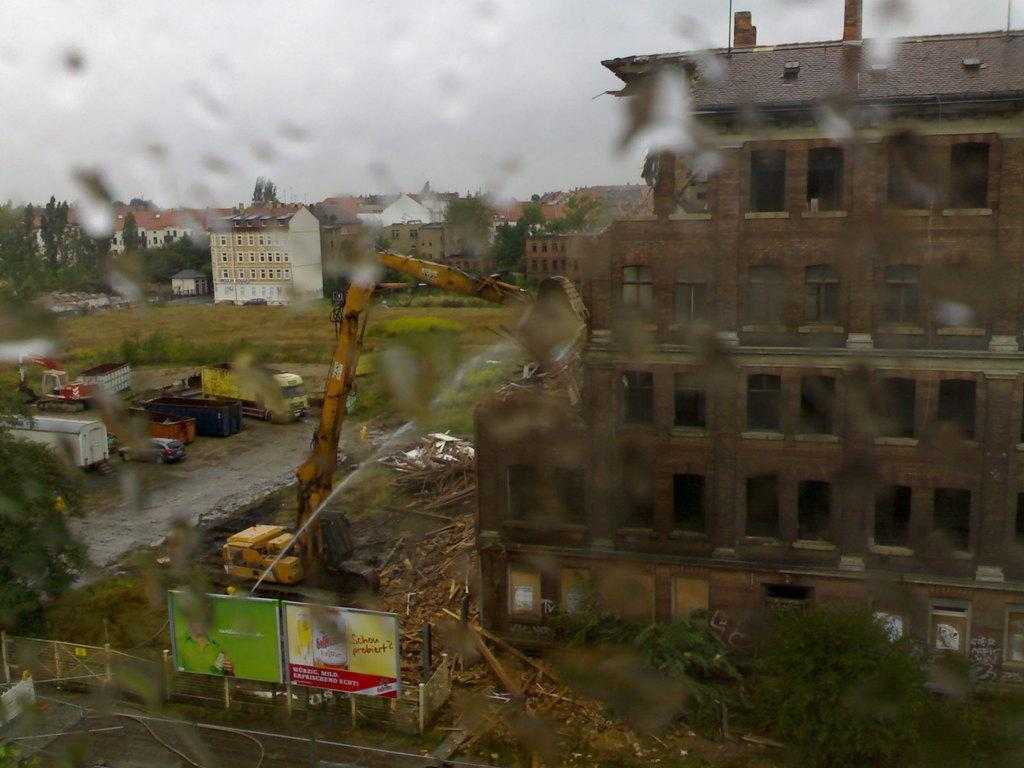What object is present in the image that has a transparent surface? There is a glass in the image. What can be seen through the glass in the image? Vehicles, buildings, trees, banners, and grass can be seen through the glass in the image. What is visible at the top of the image? The sky is visible at the top of the image. Can you see a rabbit playing with a nut in the image? There is no rabbit or nut present in the image. What type of amusement park can be seen through the glass in the image? There is no amusement park visible through the glass in the image. 